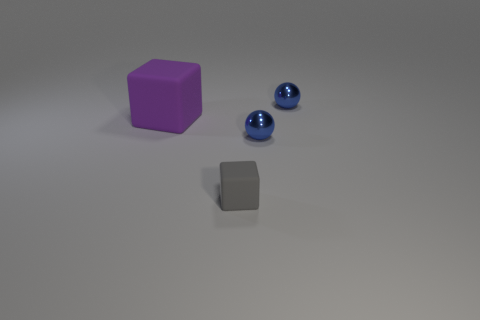The small rubber block has what color?
Provide a short and direct response. Gray. Is the size of the gray cube the same as the purple thing?
Offer a terse response. No. What number of objects are matte cubes or gray rubber things?
Ensure brevity in your answer.  2. Are there the same number of objects that are right of the purple matte thing and small things?
Your response must be concise. Yes. There is a small sphere behind the rubber object to the left of the gray rubber thing; are there any blue things to the left of it?
Ensure brevity in your answer.  Yes. There is a big block that is the same material as the small gray thing; what color is it?
Ensure brevity in your answer.  Purple. There is a matte block to the left of the gray block; does it have the same color as the tiny rubber object?
Provide a succinct answer. No. What number of spheres are blue objects or purple matte objects?
Provide a succinct answer. 2. There is a sphere in front of the small thing that is behind the tiny metallic object that is in front of the purple thing; what size is it?
Your response must be concise. Small. What shape is the small gray object?
Your response must be concise. Cube. 